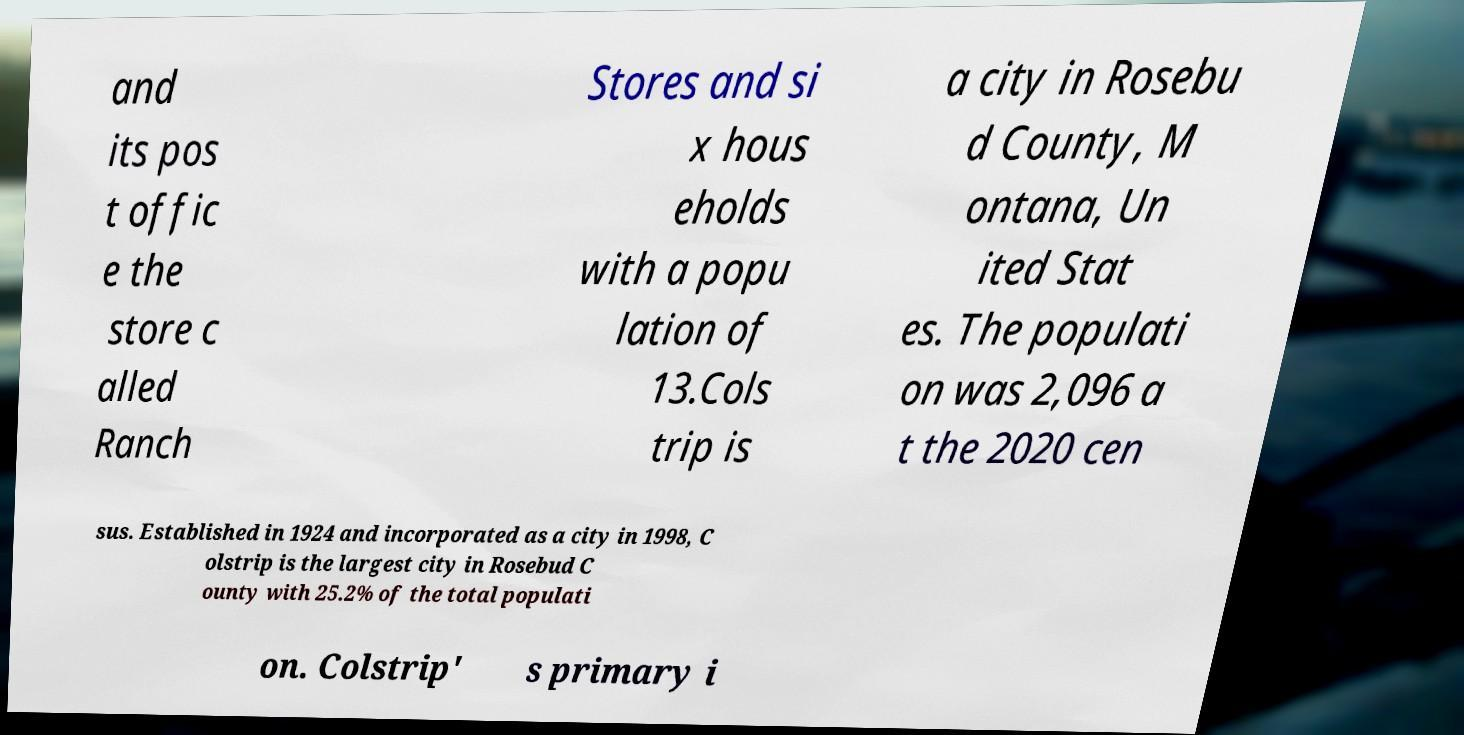There's text embedded in this image that I need extracted. Can you transcribe it verbatim? and its pos t offic e the store c alled Ranch Stores and si x hous eholds with a popu lation of 13.Cols trip is a city in Rosebu d County, M ontana, Un ited Stat es. The populati on was 2,096 a t the 2020 cen sus. Established in 1924 and incorporated as a city in 1998, C olstrip is the largest city in Rosebud C ounty with 25.2% of the total populati on. Colstrip' s primary i 